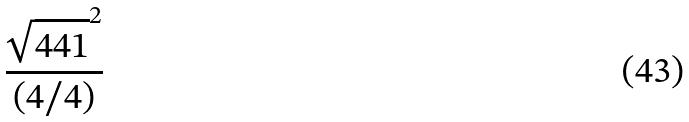<formula> <loc_0><loc_0><loc_500><loc_500>\frac { \sqrt { 4 4 1 } ^ { 2 } } { ( 4 / 4 ) }</formula> 